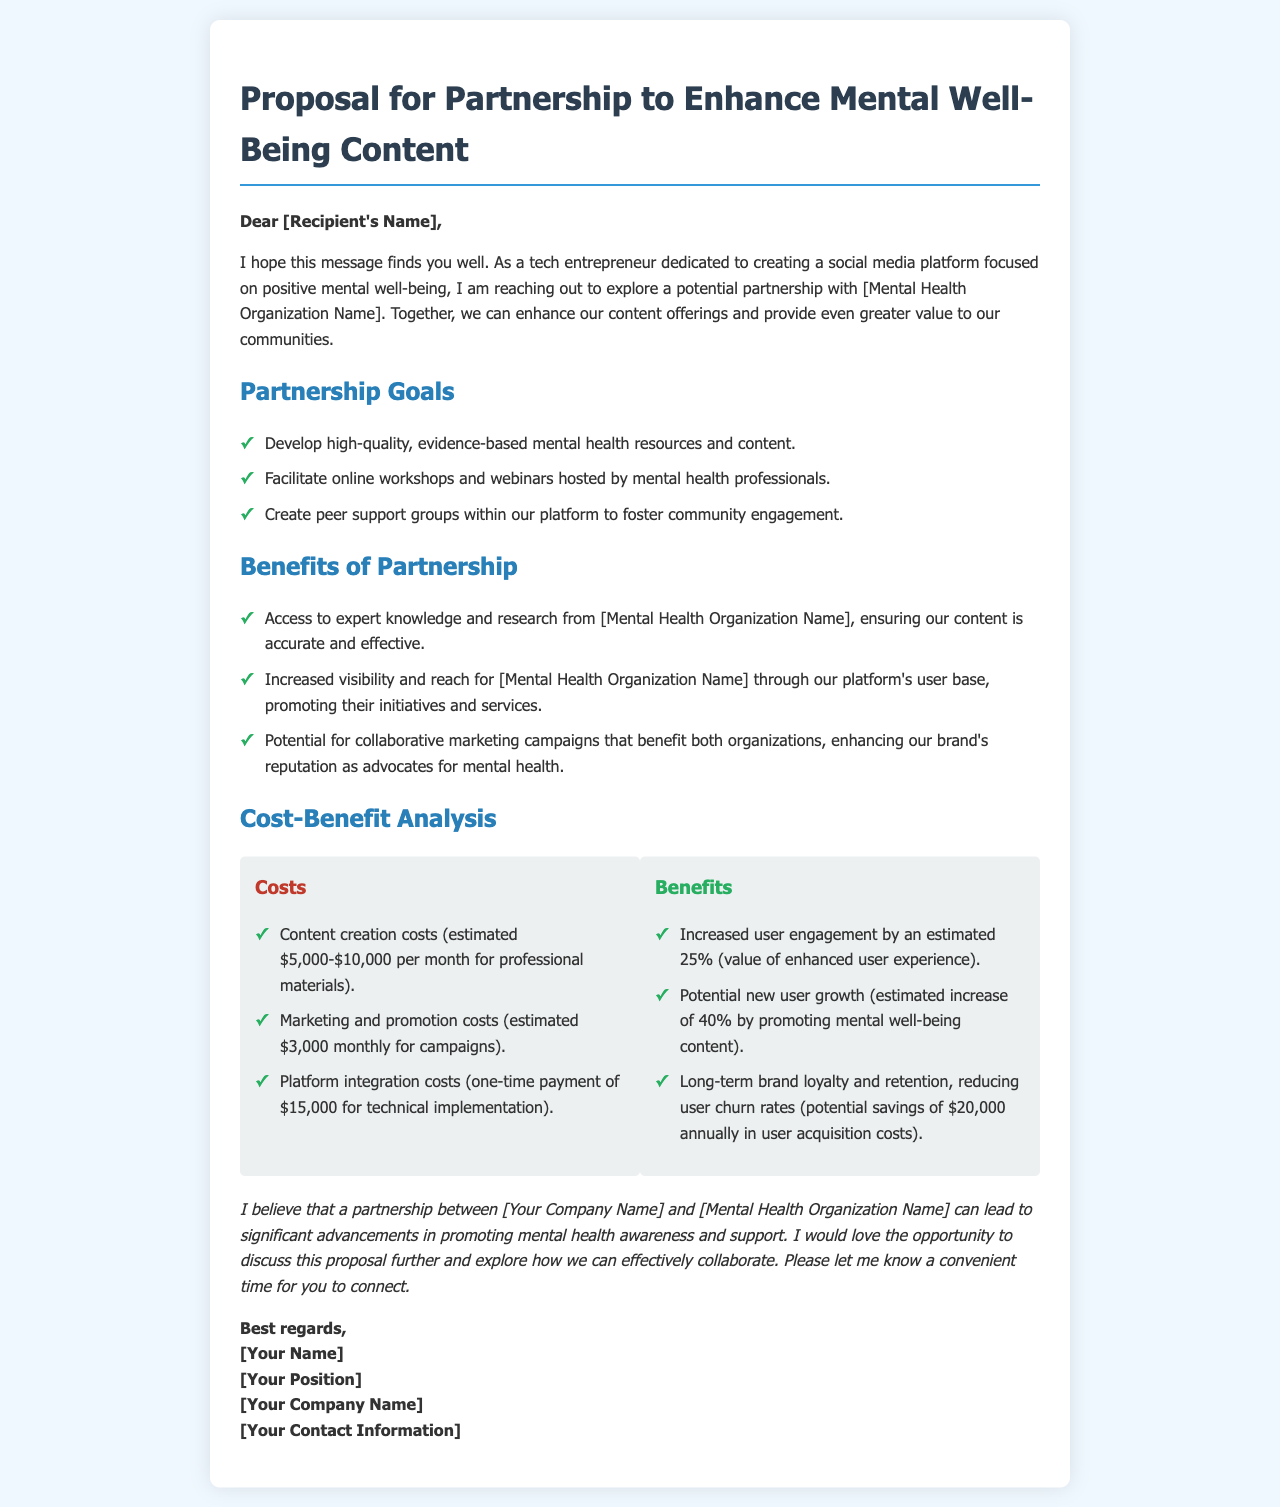What is the purpose of the partnership? The proposal seeks to enhance content offerings that promote mental well-being through collaboration.
Answer: Enhance content offerings What are the estimated content creation costs? The document specifies the range of expenses associated with content creation.
Answer: $5,000-$10,000 per month What percentage increase in user engagement is estimated? The document provides a specific estimate for increased user engagement as a result of the partnership.
Answer: 25% What is the one-time payment for platform integration? The document details the technical implementation cost required for partnership integration.
Answer: $15,000 Who is the recipient of the proposal? The document specifies an address at the beginning but uses a placeholder for the recipient's name.
Answer: [Recipient's Name] What is the potential increase in new user growth? The document states an estimated percentage increase in users due to mental well-being content promotion.
Answer: 40% What kind of workshops is the partnership expected to facilitate? The proposal mentions a specific type of events that would occur as part of the partnership.
Answer: Online workshops What can increase the visibility of the mental health organization? The proposal outlines a specific benefit that comes with the partnership for the organization.
Answer: Access to platform's user base What is the estimated annual savings in user acquisition costs? The document mentions potential financial savings related to user retention as a benefit.
Answer: $20,000 annually 